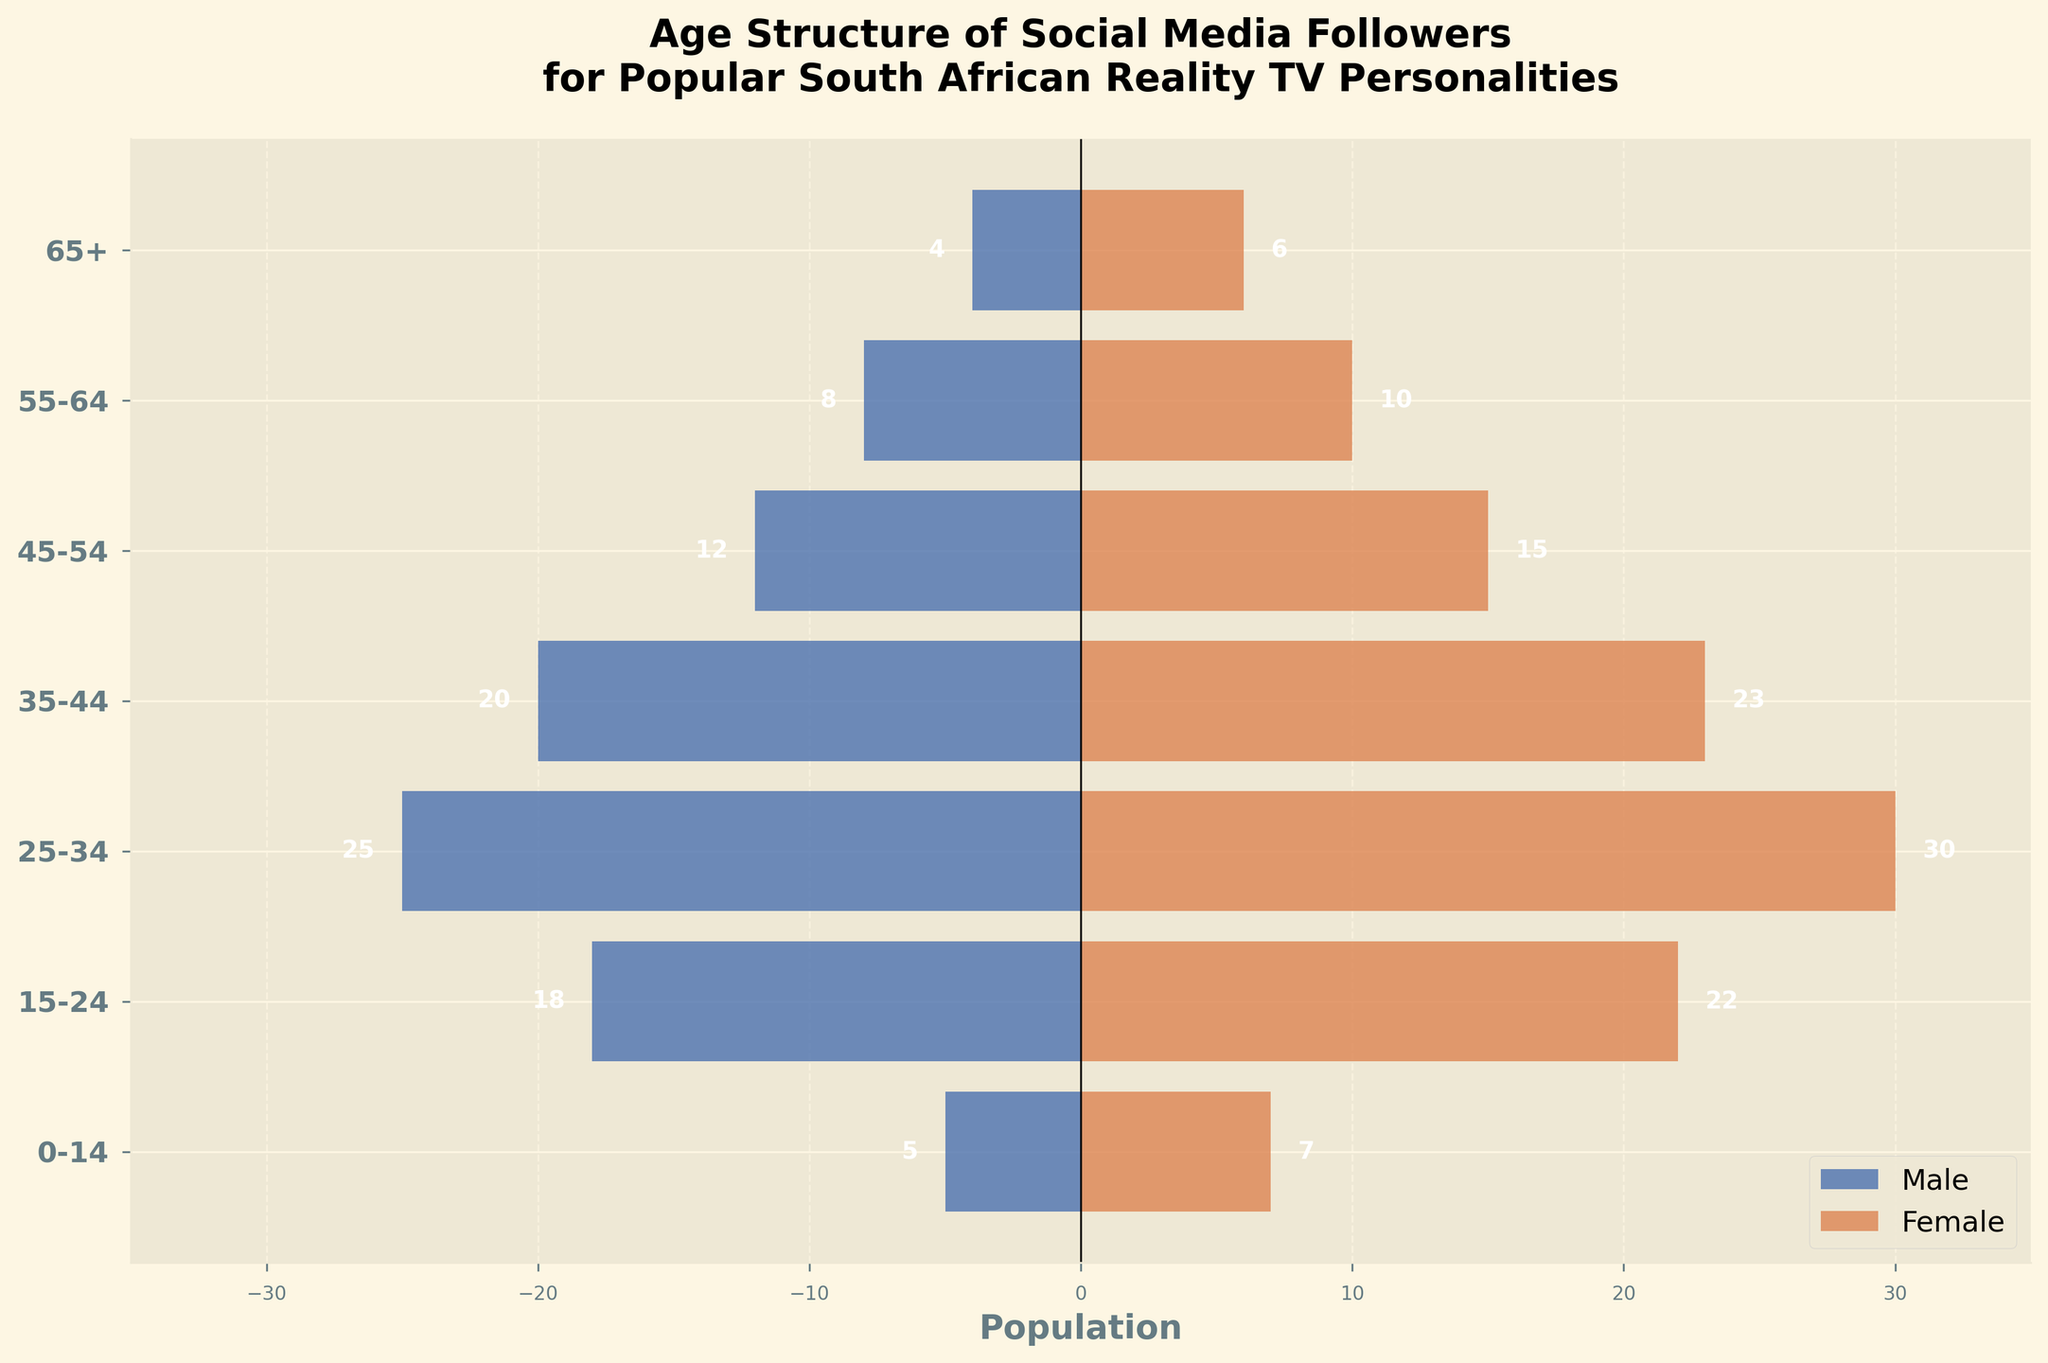What is the title of the figure? The title is displayed at the top of the figure and provides a clear description of what the figure represents. The full text can be read directly from the figure.
Answer: Age Structure of Social Media Followers for Popular South African Reality TV Personalities How many age groups are represented in the figure? The age groups are listed on the y-axis of the figure. By counting the number of unique labels, you can determine the total number of age groups.
Answer: 7 Which age group has the highest number of female followers? Look at the bars on the right side of the pyramid (which represent female followers) and identify the longest bar. The corresponding age group is the one with the highest number of female followers.
Answer: 25-34 What is the difference in the number of followers between males and females in the 15-24 age group? First, identify the values for males (18) and females (22) in the 15-24 age group. Then, subtract the male value from the female value to get the difference.
Answer: 4 What age group has the smallest number of total followers? Add the number of male followers and female followers for each age group. The age group with the smallest sum is the one with the smallest number of total followers.
Answer: 65+ How many more female followers are there compared to male followers in the 45-54 age group? Find the values for males (12) and females (15) in the 45-54 age group. Subtract the male value from the female value to calculate the difference.
Answer: 3 Which age group has more male followers than female followers? Compare the lengths of the bars for males (left side) and females (right side) for each age group. Identify the age group where the male bar is longer than the female bar.
Answer: No age group What is the total number of followers in the 35-44 age group? Add the number of male followers (20) to the number of female followers (23) in the 35-44 age group to get the total.
Answer: 43 Which gender has more followers overall in the 55-64 age group? Compare the lengths of the bars for males (8) and females (10) in the 55-64 age group. The longer bar represents the gender with more followers.
Answer: Female 